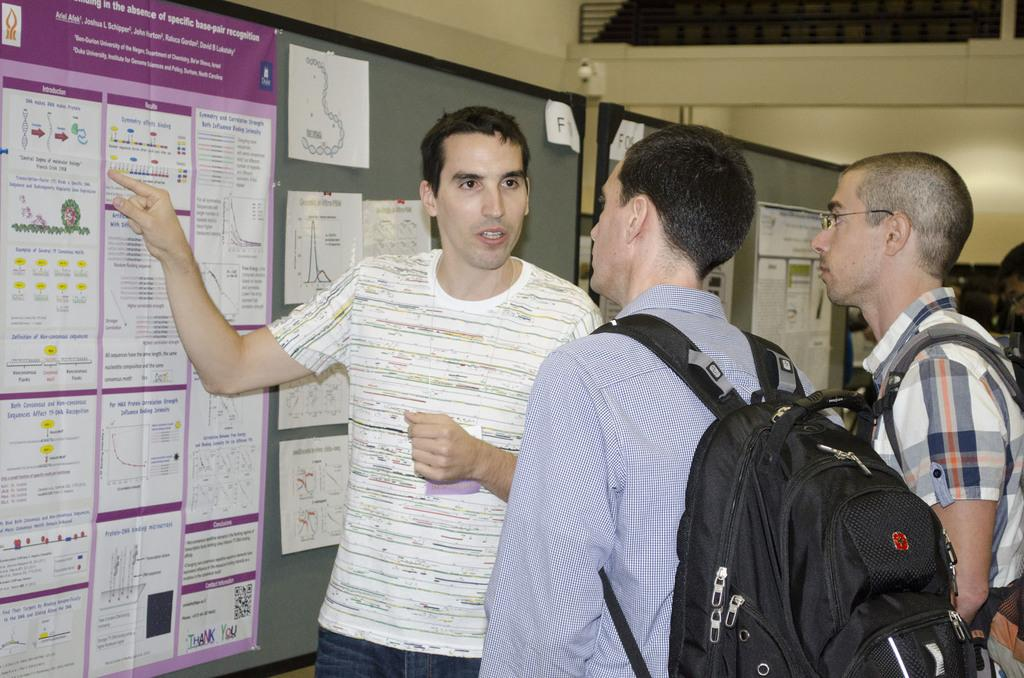Provide a one-sentence caption for the provided image. Man pointing at a bulletin board that says "Introduction". 